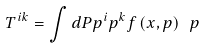<formula> <loc_0><loc_0><loc_500><loc_500>T ^ { i k } = \int d P p ^ { i } p ^ { k } f \left ( x , p \right ) \ p</formula> 